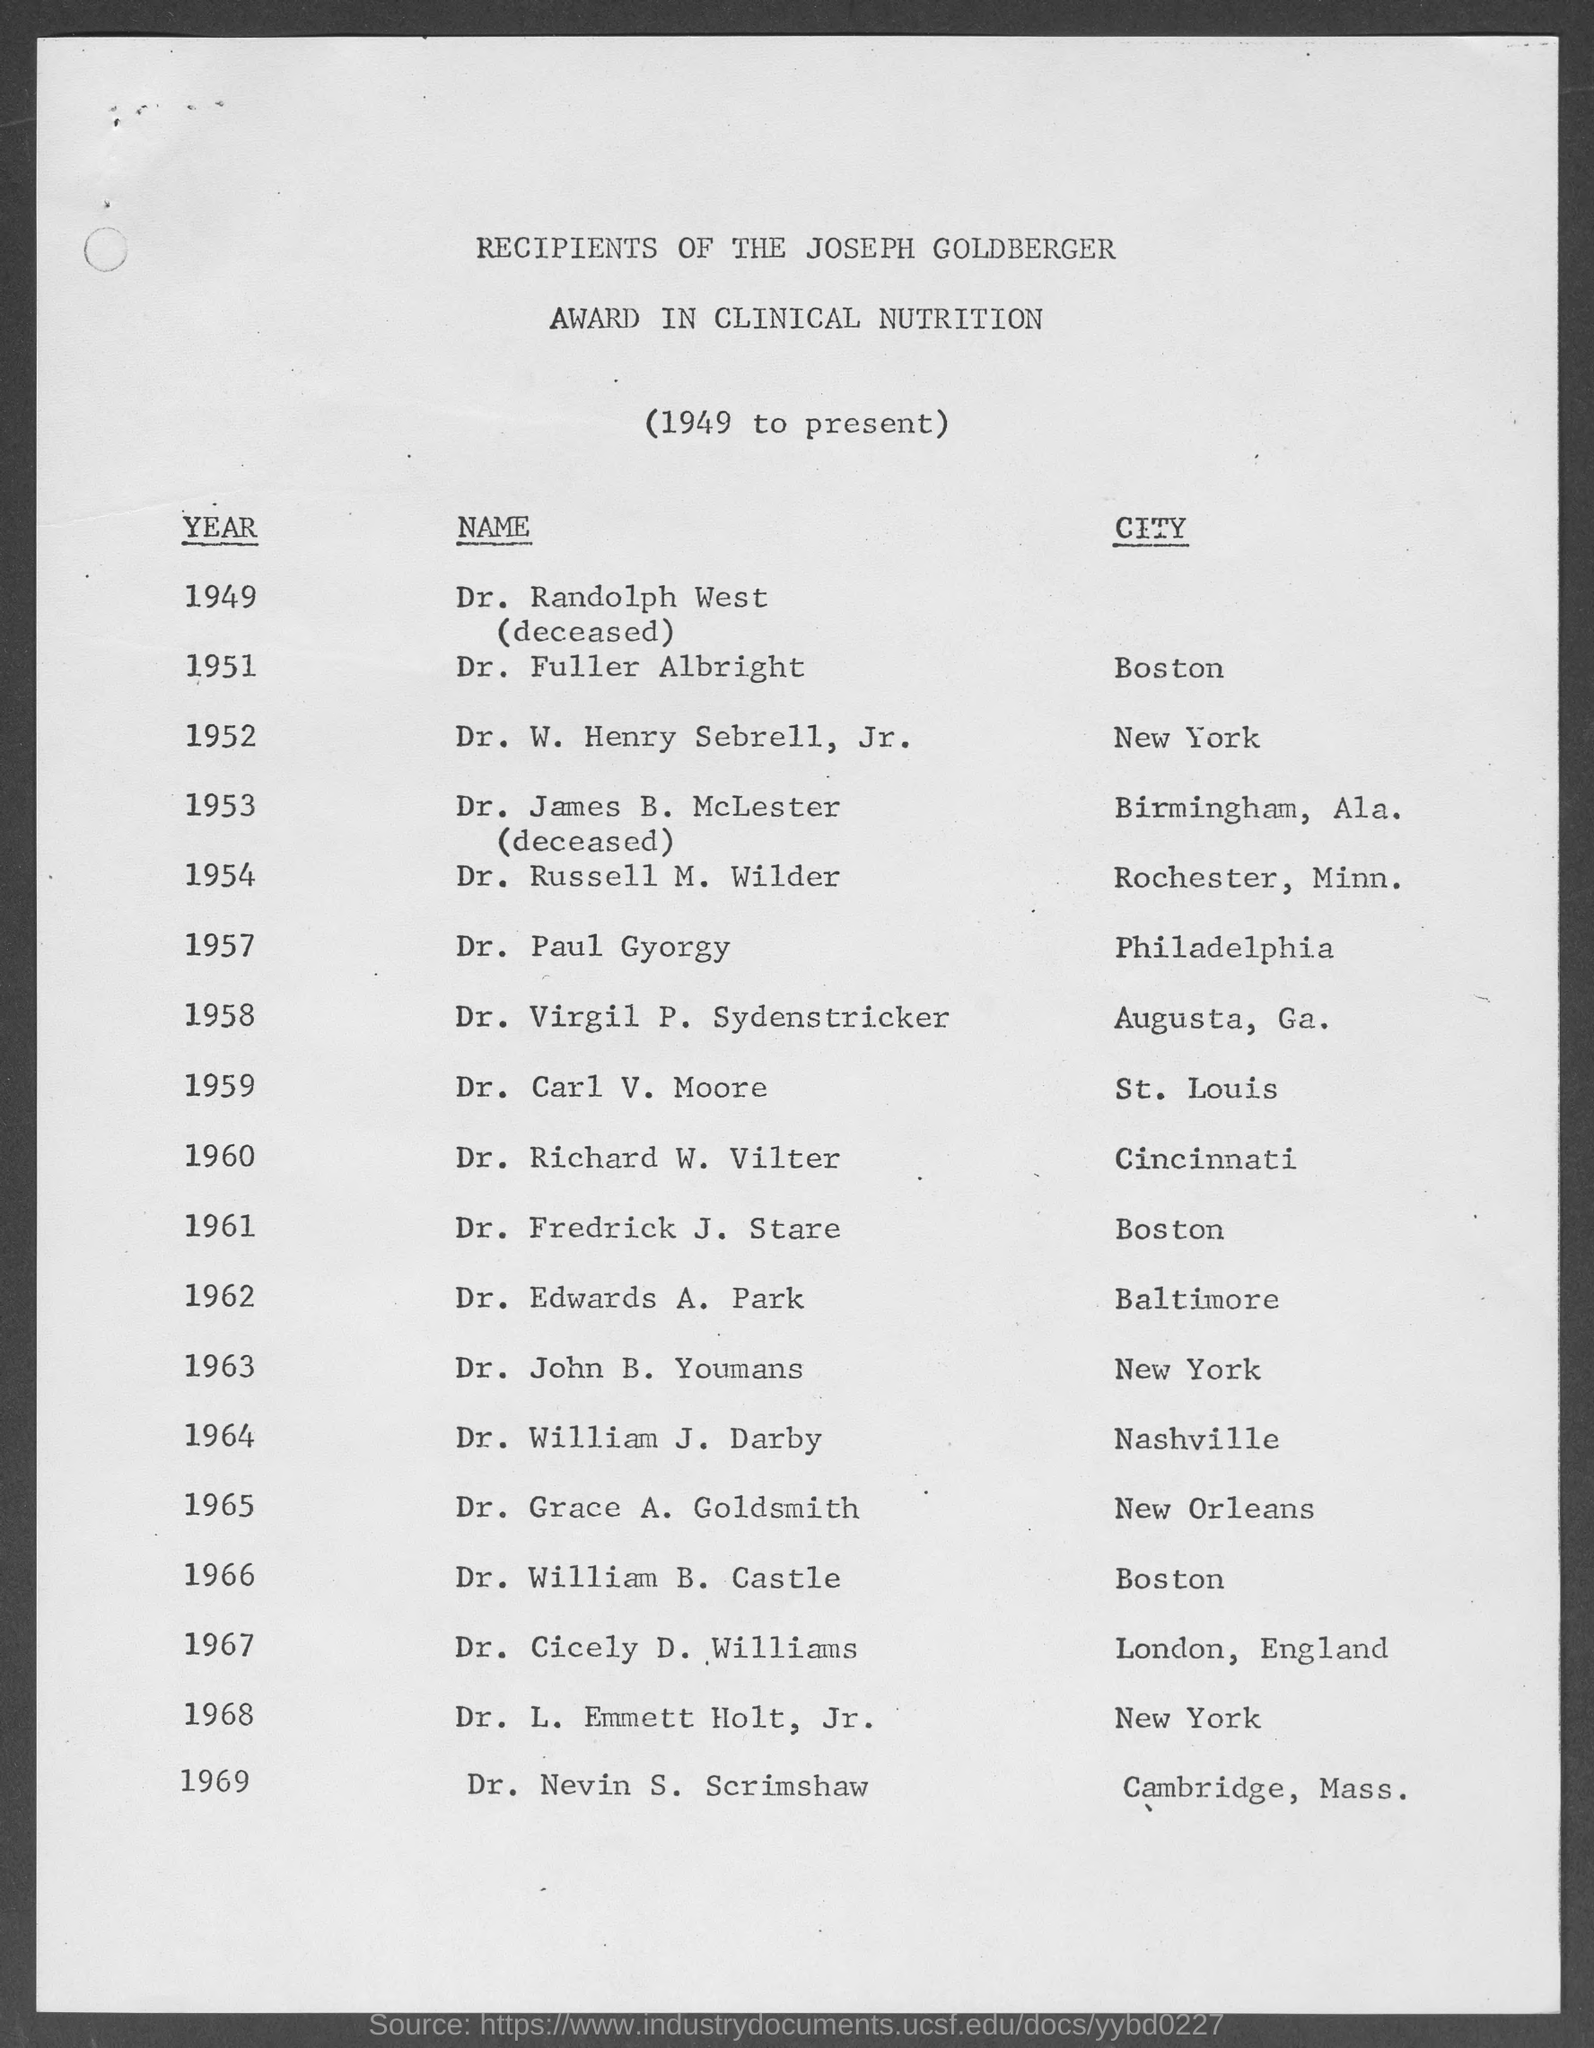Point out several critical features in this image. In 1959, Dr. Carl V. Moore received the Joseph Goldberger Award for his outstanding contributions to the field of public health. The Joseph Goldberger Award in Clinical Nutrition was awarded to Dr. William B. Castle in the year 1966. In 1962, Dr. Edwards D. Park won the Joseph Goldberger Award. The Joseph Goldberger Award in Clinical Nutrition was presented to Dr. Paul Gyorgy for the year 1957. Dr. William J. Darby was awarded the Joseph Goldberger Award in 1964. 